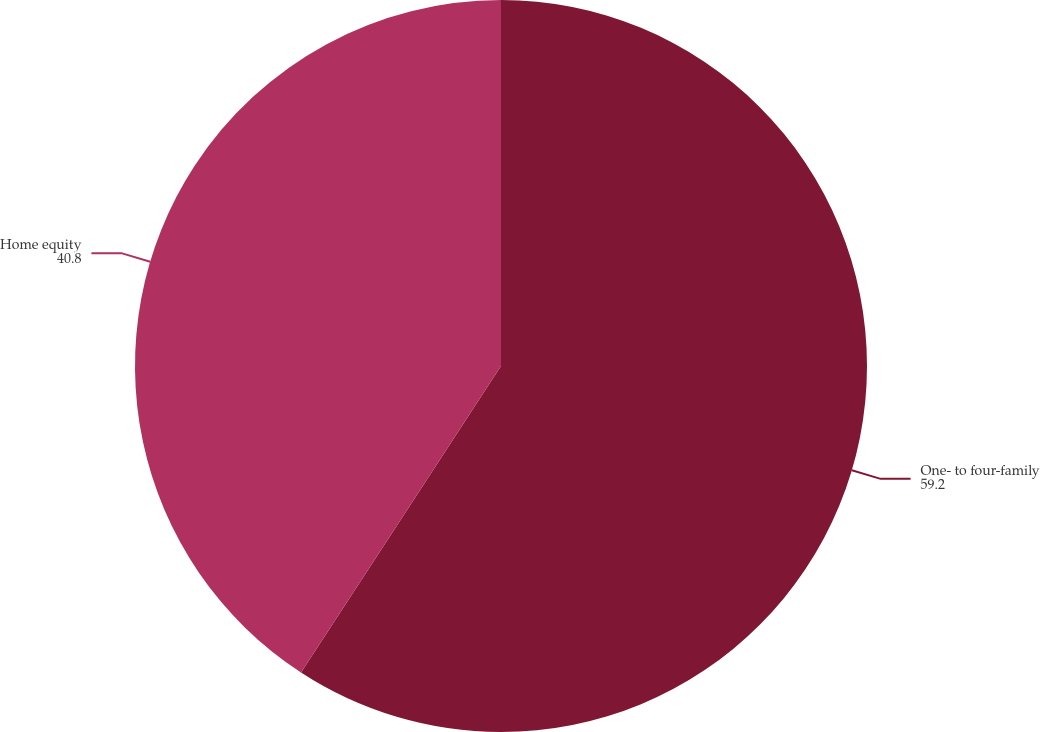Convert chart. <chart><loc_0><loc_0><loc_500><loc_500><pie_chart><fcel>One- to four-family<fcel>Home equity<nl><fcel>59.2%<fcel>40.8%<nl></chart> 